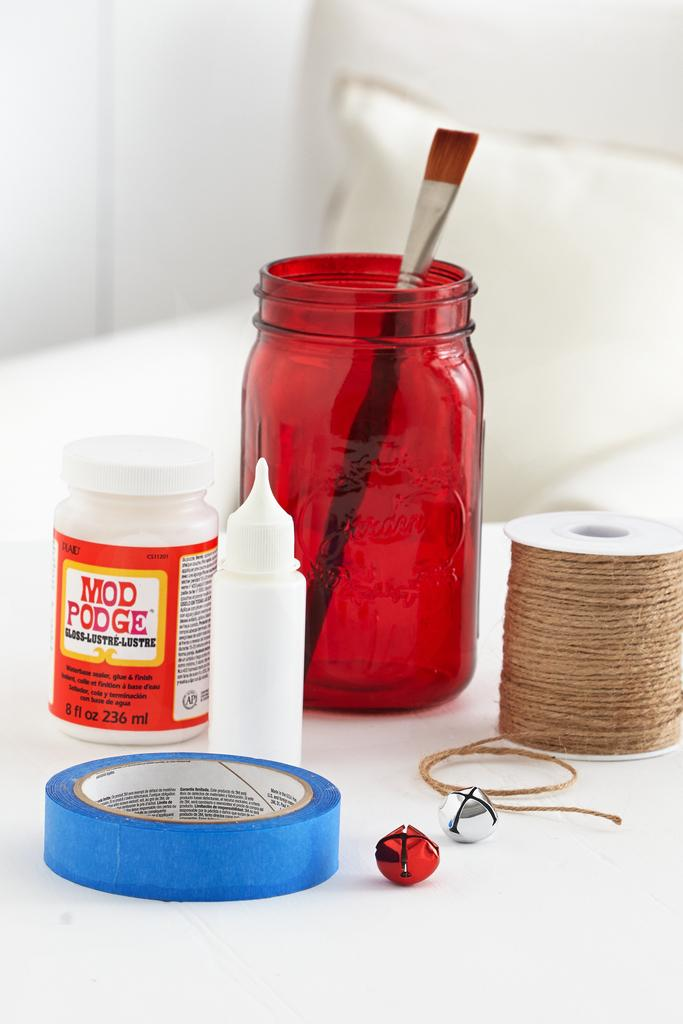<image>
Render a clear and concise summary of the photo. Crafting supplies, including Mod Podge, are arranged on a white table. 